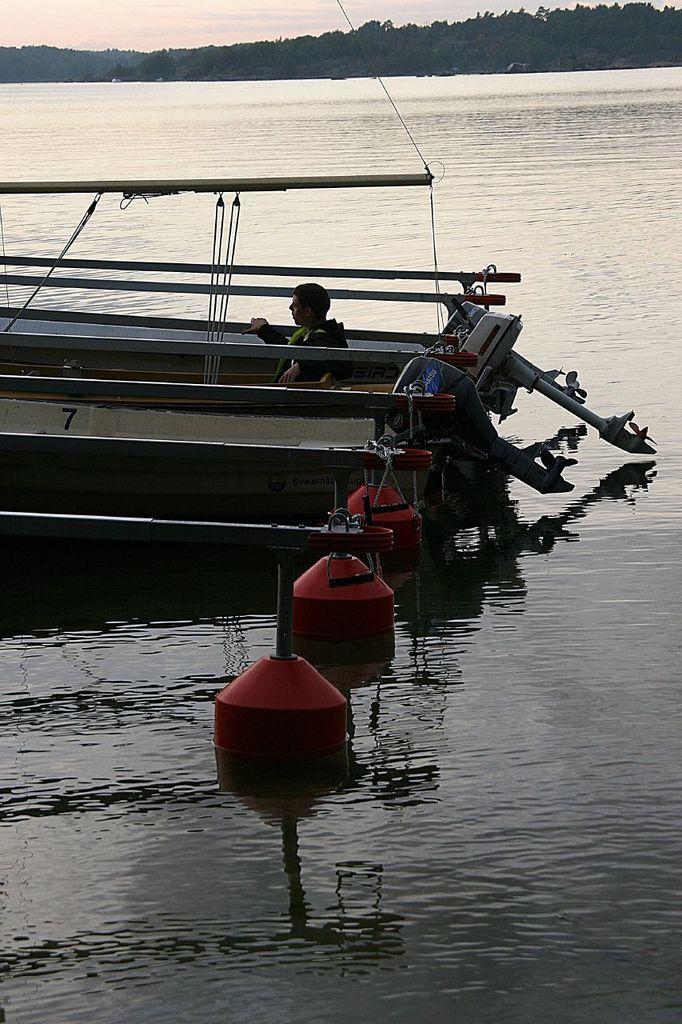In one or two sentences, can you explain what this image depicts? In this image I can see the water and few objects which are red in color on the surface of the water. I can see a boat which is white and cream in color on the surface of the water. I can see a person is sitting in the boat. In the background I can see few trees and the sky. 